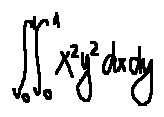<formula> <loc_0><loc_0><loc_500><loc_500>\int \lim i t s _ { 0 } ^ { 1 } \int \lim i t s _ { 0 } ^ { 1 } x ^ { 2 } y ^ { 2 } d x d y</formula> 